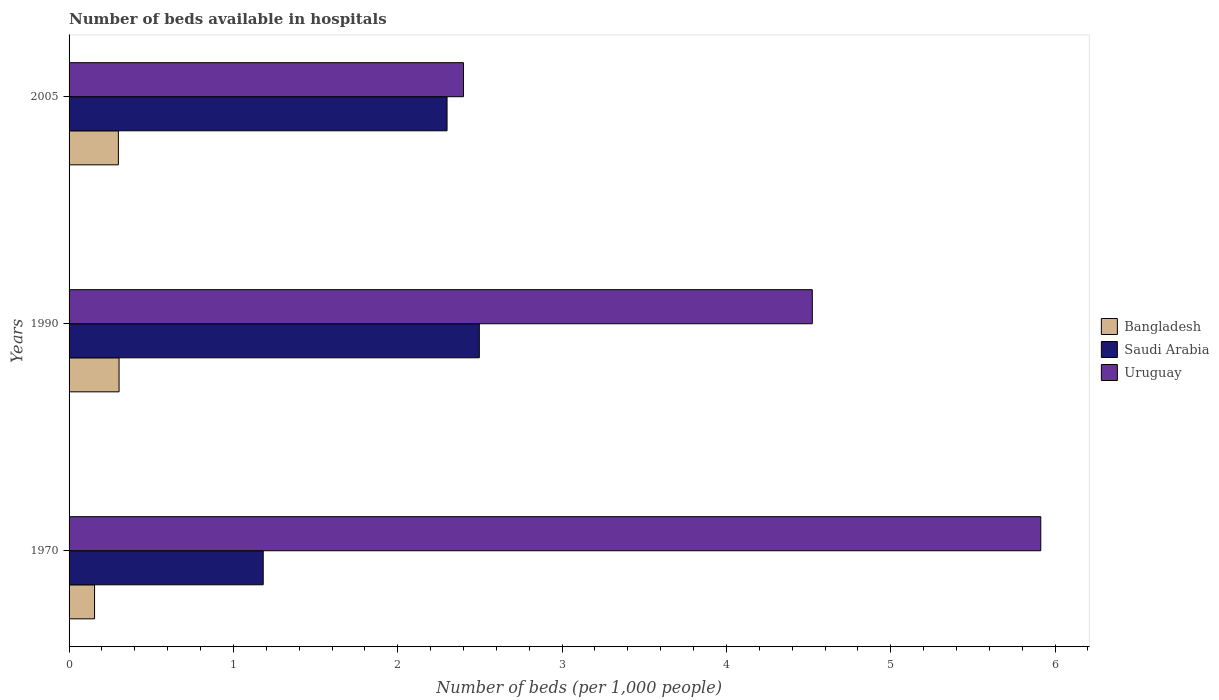How many different coloured bars are there?
Provide a succinct answer. 3. Are the number of bars per tick equal to the number of legend labels?
Provide a short and direct response. Yes. How many bars are there on the 3rd tick from the bottom?
Your answer should be compact. 3. What is the number of beds in the hospiatls of in Uruguay in 1990?
Make the answer very short. 4.52. Across all years, what is the maximum number of beds in the hospiatls of in Saudi Arabia?
Keep it short and to the point. 2.5. Across all years, what is the minimum number of beds in the hospiatls of in Bangladesh?
Your answer should be very brief. 0.16. In which year was the number of beds in the hospiatls of in Bangladesh maximum?
Give a very brief answer. 1990. In which year was the number of beds in the hospiatls of in Saudi Arabia minimum?
Make the answer very short. 1970. What is the total number of beds in the hospiatls of in Saudi Arabia in the graph?
Provide a succinct answer. 5.98. What is the difference between the number of beds in the hospiatls of in Uruguay in 1970 and that in 2005?
Your answer should be compact. 3.51. What is the difference between the number of beds in the hospiatls of in Uruguay in 1990 and the number of beds in the hospiatls of in Saudi Arabia in 2005?
Give a very brief answer. 2.22. What is the average number of beds in the hospiatls of in Saudi Arabia per year?
Offer a terse response. 1.99. In the year 2005, what is the difference between the number of beds in the hospiatls of in Uruguay and number of beds in the hospiatls of in Bangladesh?
Offer a very short reply. 2.1. What is the ratio of the number of beds in the hospiatls of in Saudi Arabia in 1970 to that in 1990?
Provide a succinct answer. 0.47. Is the number of beds in the hospiatls of in Bangladesh in 1970 less than that in 1990?
Your answer should be compact. Yes. Is the difference between the number of beds in the hospiatls of in Uruguay in 1970 and 1990 greater than the difference between the number of beds in the hospiatls of in Bangladesh in 1970 and 1990?
Provide a short and direct response. Yes. What is the difference between the highest and the second highest number of beds in the hospiatls of in Uruguay?
Your response must be concise. 1.39. What is the difference between the highest and the lowest number of beds in the hospiatls of in Bangladesh?
Provide a short and direct response. 0.15. In how many years, is the number of beds in the hospiatls of in Saudi Arabia greater than the average number of beds in the hospiatls of in Saudi Arabia taken over all years?
Your response must be concise. 2. What does the 1st bar from the top in 2005 represents?
Offer a terse response. Uruguay. What does the 3rd bar from the bottom in 1990 represents?
Your answer should be compact. Uruguay. Is it the case that in every year, the sum of the number of beds in the hospiatls of in Uruguay and number of beds in the hospiatls of in Bangladesh is greater than the number of beds in the hospiatls of in Saudi Arabia?
Provide a short and direct response. Yes. How many bars are there?
Provide a short and direct response. 9. Are all the bars in the graph horizontal?
Offer a very short reply. Yes. Are the values on the major ticks of X-axis written in scientific E-notation?
Provide a succinct answer. No. How many legend labels are there?
Make the answer very short. 3. What is the title of the graph?
Make the answer very short. Number of beds available in hospitals. What is the label or title of the X-axis?
Make the answer very short. Number of beds (per 1,0 people). What is the label or title of the Y-axis?
Your response must be concise. Years. What is the Number of beds (per 1,000 people) of Bangladesh in 1970?
Your answer should be compact. 0.16. What is the Number of beds (per 1,000 people) in Saudi Arabia in 1970?
Make the answer very short. 1.18. What is the Number of beds (per 1,000 people) of Uruguay in 1970?
Provide a short and direct response. 5.91. What is the Number of beds (per 1,000 people) in Bangladesh in 1990?
Your answer should be very brief. 0.3. What is the Number of beds (per 1,000 people) of Saudi Arabia in 1990?
Your answer should be very brief. 2.5. What is the Number of beds (per 1,000 people) in Uruguay in 1990?
Ensure brevity in your answer.  4.52. What is the Number of beds (per 1,000 people) of Saudi Arabia in 2005?
Offer a terse response. 2.3. What is the Number of beds (per 1,000 people) of Uruguay in 2005?
Offer a very short reply. 2.4. Across all years, what is the maximum Number of beds (per 1,000 people) of Bangladesh?
Offer a very short reply. 0.3. Across all years, what is the maximum Number of beds (per 1,000 people) of Saudi Arabia?
Your answer should be very brief. 2.5. Across all years, what is the maximum Number of beds (per 1,000 people) of Uruguay?
Make the answer very short. 5.91. Across all years, what is the minimum Number of beds (per 1,000 people) of Bangladesh?
Provide a short and direct response. 0.16. Across all years, what is the minimum Number of beds (per 1,000 people) of Saudi Arabia?
Provide a succinct answer. 1.18. What is the total Number of beds (per 1,000 people) of Bangladesh in the graph?
Offer a terse response. 0.76. What is the total Number of beds (per 1,000 people) of Saudi Arabia in the graph?
Offer a terse response. 5.98. What is the total Number of beds (per 1,000 people) in Uruguay in the graph?
Give a very brief answer. 12.84. What is the difference between the Number of beds (per 1,000 people) of Bangladesh in 1970 and that in 1990?
Ensure brevity in your answer.  -0.15. What is the difference between the Number of beds (per 1,000 people) in Saudi Arabia in 1970 and that in 1990?
Keep it short and to the point. -1.31. What is the difference between the Number of beds (per 1,000 people) of Uruguay in 1970 and that in 1990?
Give a very brief answer. 1.39. What is the difference between the Number of beds (per 1,000 people) in Bangladesh in 1970 and that in 2005?
Make the answer very short. -0.14. What is the difference between the Number of beds (per 1,000 people) of Saudi Arabia in 1970 and that in 2005?
Give a very brief answer. -1.12. What is the difference between the Number of beds (per 1,000 people) of Uruguay in 1970 and that in 2005?
Offer a terse response. 3.51. What is the difference between the Number of beds (per 1,000 people) in Bangladesh in 1990 and that in 2005?
Provide a succinct answer. 0. What is the difference between the Number of beds (per 1,000 people) in Saudi Arabia in 1990 and that in 2005?
Offer a very short reply. 0.2. What is the difference between the Number of beds (per 1,000 people) in Uruguay in 1990 and that in 2005?
Keep it short and to the point. 2.12. What is the difference between the Number of beds (per 1,000 people) in Bangladesh in 1970 and the Number of beds (per 1,000 people) in Saudi Arabia in 1990?
Offer a terse response. -2.34. What is the difference between the Number of beds (per 1,000 people) in Bangladesh in 1970 and the Number of beds (per 1,000 people) in Uruguay in 1990?
Keep it short and to the point. -4.37. What is the difference between the Number of beds (per 1,000 people) in Saudi Arabia in 1970 and the Number of beds (per 1,000 people) in Uruguay in 1990?
Keep it short and to the point. -3.34. What is the difference between the Number of beds (per 1,000 people) in Bangladesh in 1970 and the Number of beds (per 1,000 people) in Saudi Arabia in 2005?
Your answer should be compact. -2.14. What is the difference between the Number of beds (per 1,000 people) in Bangladesh in 1970 and the Number of beds (per 1,000 people) in Uruguay in 2005?
Make the answer very short. -2.24. What is the difference between the Number of beds (per 1,000 people) in Saudi Arabia in 1970 and the Number of beds (per 1,000 people) in Uruguay in 2005?
Your answer should be compact. -1.22. What is the difference between the Number of beds (per 1,000 people) in Bangladesh in 1990 and the Number of beds (per 1,000 people) in Saudi Arabia in 2005?
Make the answer very short. -2. What is the difference between the Number of beds (per 1,000 people) in Bangladesh in 1990 and the Number of beds (per 1,000 people) in Uruguay in 2005?
Offer a terse response. -2.1. What is the difference between the Number of beds (per 1,000 people) in Saudi Arabia in 1990 and the Number of beds (per 1,000 people) in Uruguay in 2005?
Make the answer very short. 0.1. What is the average Number of beds (per 1,000 people) in Bangladesh per year?
Provide a short and direct response. 0.25. What is the average Number of beds (per 1,000 people) in Saudi Arabia per year?
Make the answer very short. 1.99. What is the average Number of beds (per 1,000 people) of Uruguay per year?
Provide a short and direct response. 4.28. In the year 1970, what is the difference between the Number of beds (per 1,000 people) of Bangladesh and Number of beds (per 1,000 people) of Saudi Arabia?
Provide a short and direct response. -1.03. In the year 1970, what is the difference between the Number of beds (per 1,000 people) in Bangladesh and Number of beds (per 1,000 people) in Uruguay?
Offer a terse response. -5.76. In the year 1970, what is the difference between the Number of beds (per 1,000 people) in Saudi Arabia and Number of beds (per 1,000 people) in Uruguay?
Offer a terse response. -4.73. In the year 1990, what is the difference between the Number of beds (per 1,000 people) in Bangladesh and Number of beds (per 1,000 people) in Saudi Arabia?
Your answer should be very brief. -2.19. In the year 1990, what is the difference between the Number of beds (per 1,000 people) in Bangladesh and Number of beds (per 1,000 people) in Uruguay?
Your response must be concise. -4.22. In the year 1990, what is the difference between the Number of beds (per 1,000 people) in Saudi Arabia and Number of beds (per 1,000 people) in Uruguay?
Your response must be concise. -2.03. In the year 2005, what is the difference between the Number of beds (per 1,000 people) in Bangladesh and Number of beds (per 1,000 people) in Saudi Arabia?
Provide a short and direct response. -2. In the year 2005, what is the difference between the Number of beds (per 1,000 people) in Saudi Arabia and Number of beds (per 1,000 people) in Uruguay?
Provide a short and direct response. -0.1. What is the ratio of the Number of beds (per 1,000 people) of Bangladesh in 1970 to that in 1990?
Offer a terse response. 0.51. What is the ratio of the Number of beds (per 1,000 people) in Saudi Arabia in 1970 to that in 1990?
Give a very brief answer. 0.47. What is the ratio of the Number of beds (per 1,000 people) in Uruguay in 1970 to that in 1990?
Provide a short and direct response. 1.31. What is the ratio of the Number of beds (per 1,000 people) in Bangladesh in 1970 to that in 2005?
Provide a short and direct response. 0.52. What is the ratio of the Number of beds (per 1,000 people) of Saudi Arabia in 1970 to that in 2005?
Your response must be concise. 0.51. What is the ratio of the Number of beds (per 1,000 people) of Uruguay in 1970 to that in 2005?
Provide a succinct answer. 2.46. What is the ratio of the Number of beds (per 1,000 people) in Saudi Arabia in 1990 to that in 2005?
Your answer should be very brief. 1.09. What is the ratio of the Number of beds (per 1,000 people) of Uruguay in 1990 to that in 2005?
Ensure brevity in your answer.  1.88. What is the difference between the highest and the second highest Number of beds (per 1,000 people) of Bangladesh?
Provide a short and direct response. 0. What is the difference between the highest and the second highest Number of beds (per 1,000 people) in Saudi Arabia?
Offer a very short reply. 0.2. What is the difference between the highest and the second highest Number of beds (per 1,000 people) in Uruguay?
Make the answer very short. 1.39. What is the difference between the highest and the lowest Number of beds (per 1,000 people) of Bangladesh?
Ensure brevity in your answer.  0.15. What is the difference between the highest and the lowest Number of beds (per 1,000 people) of Saudi Arabia?
Your answer should be very brief. 1.31. What is the difference between the highest and the lowest Number of beds (per 1,000 people) in Uruguay?
Provide a succinct answer. 3.51. 